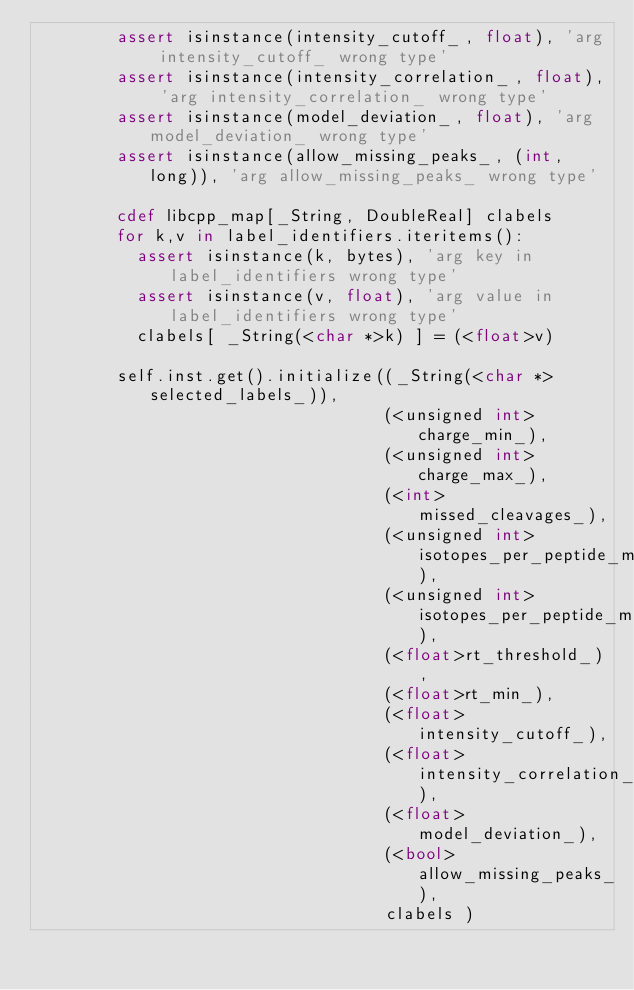Convert code to text. <code><loc_0><loc_0><loc_500><loc_500><_Cython_>        assert isinstance(intensity_cutoff_, float), 'arg intensity_cutoff_ wrong type'
        assert isinstance(intensity_correlation_, float), 'arg intensity_correlation_ wrong type'
        assert isinstance(model_deviation_, float), 'arg model_deviation_ wrong type'
        assert isinstance(allow_missing_peaks_, (int, long)), 'arg allow_missing_peaks_ wrong type'

        cdef libcpp_map[_String, DoubleReal] clabels
        for k,v in label_identifiers.iteritems():
          assert isinstance(k, bytes), 'arg key in label_identifiers wrong type'
          assert isinstance(v, float), 'arg value in label_identifiers wrong type'
          clabels[ _String(<char *>k) ] = (<float>v)

        self.inst.get().initialize((_String(<char *>selected_labels_)),
                                   (<unsigned int>charge_min_),
                                   (<unsigned int>charge_max_),
                                   (<int>missed_cleavages_),
                                   (<unsigned int>isotopes_per_peptide_min_),
                                   (<unsigned int>isotopes_per_peptide_max_),
                                   (<float>rt_threshold_),
                                   (<float>rt_min_),
                                   (<float>intensity_cutoff_),
                                   (<float>intensity_correlation_),
                                   (<float>model_deviation_),
                                   (<bool>allow_missing_peaks_),
                                   clabels ) 

</code> 